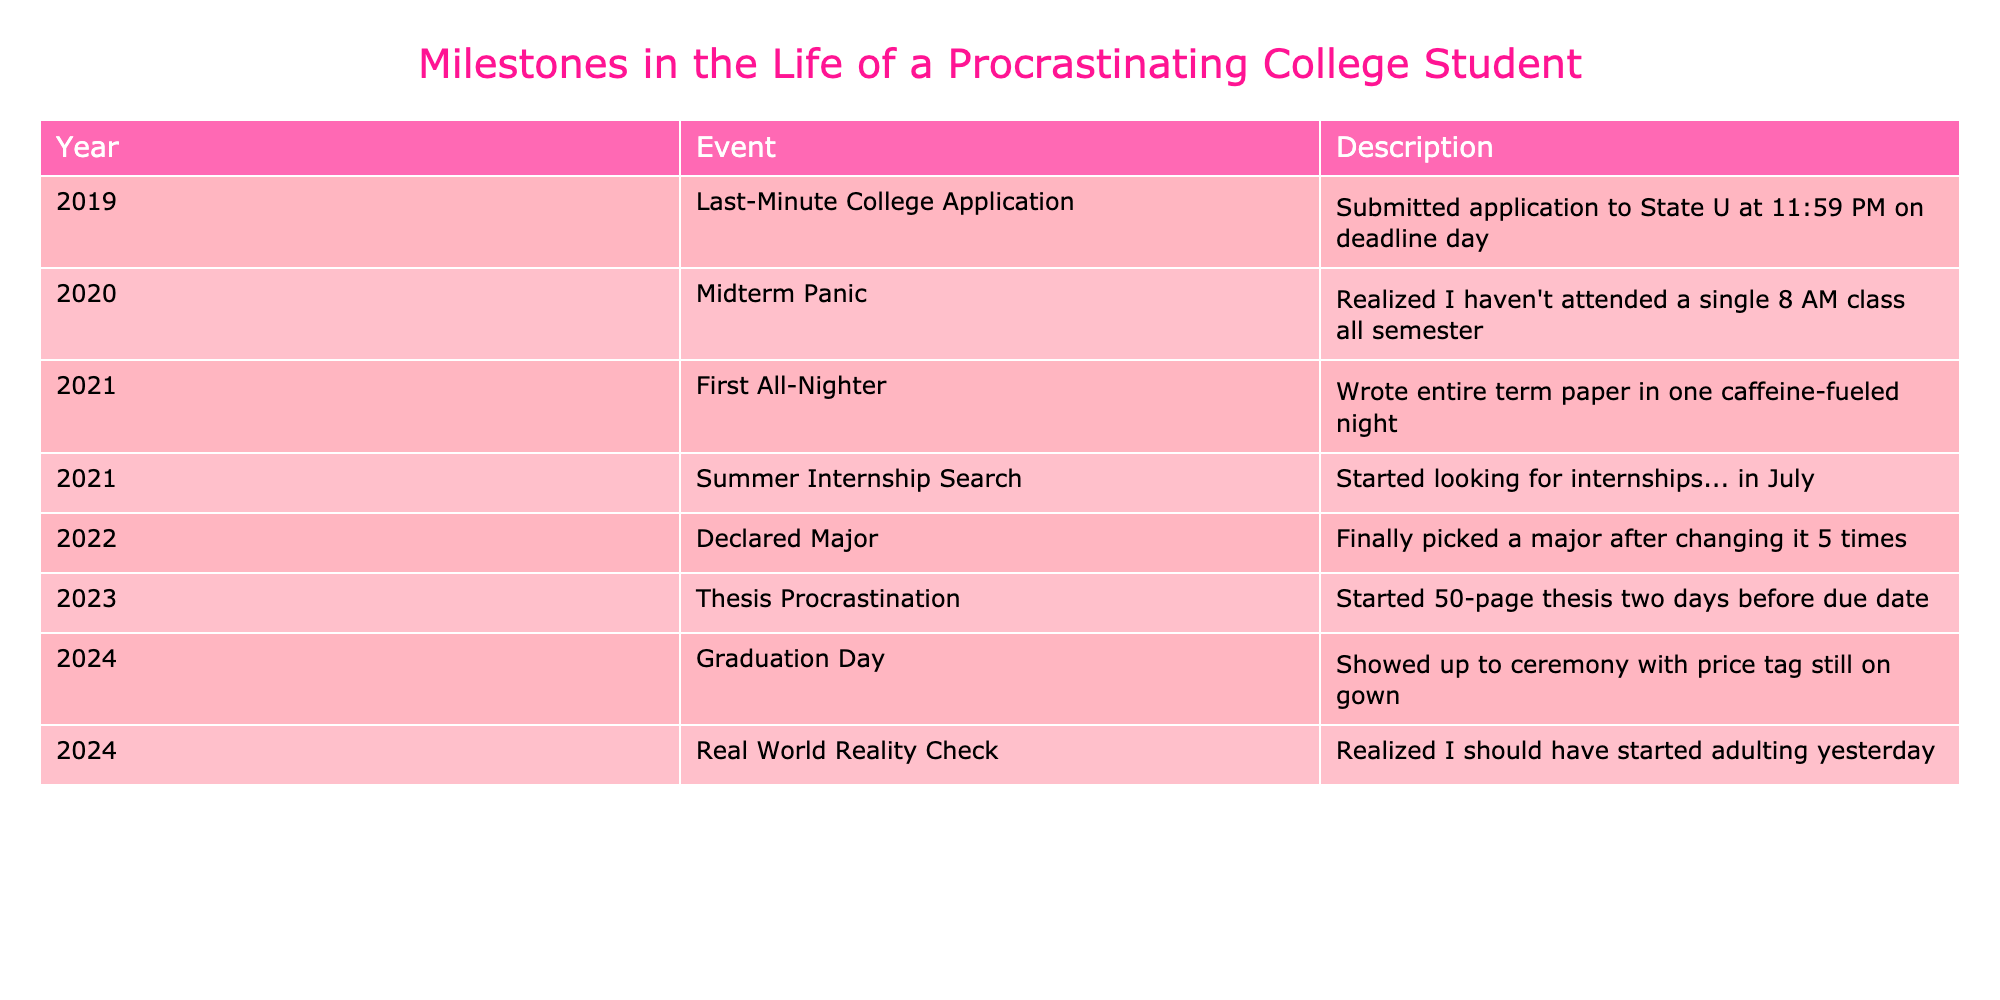What year did the student declare their major? The table shows that the student declared their major in the year 2022. This information can be directly retrieved from the "Year" column of the "Declared Major" event.
Answer: 2022 How many events happened in the year 2021? The table lists two events for the year 2021: "First All-Nighter" and "Summer Internship Search." By counting these, we see there are two events listed for that year.
Answer: 2 Was the student's thesis started before or after the due date? The table indicates that the student started their thesis two days before the due date, which clearly states the timing. Thus, it affirms that the thesis process began prior to the deadline.
Answer: Before What is the difference in years between the "Summer Internship Search" and "Graduation Day"? The "Summer Internship Search" occurred in 2021 and "Graduation Day" took place in 2024. To find the difference: 2024 - 2021 = 3 years. Therefore, the gap between these two events is three years.
Answer: 3 How many changes did the student make to their major before declaring it? The description of the "Declared Major" event mentions that the student changed their major five times before settling on one. Hence, it indicates there were five changes made.
Answer: 5 What event occurred closest to the student's graduation day? Looking at the table, the "Thesis Procrastination" event occurred in 2023, while "Graduation Day" is in 2024. Since these events are one year apart, "Thesis Procrastination" is the event that occurred closest to graduation.
Answer: Thesis Procrastination Was the student's first all-nighter related to preparing for a midterm? The "First All-Nighter" was associated with writing a term paper, while the "Midterm Panic" event mentions not attending any 8 AM classes. Since these events are about different assessments (a term paper vs. a midterm), it is correct to answer no.
Answer: No What percentage of the listed events involved procrastination explicitly? From the table, five events explicitly mention procrastination or last-minute efforts; those are "Last-Minute College Application," "Midterm Panic," "First All-Nighter," "Thesis Procrastination," and "Real World Reality Check." The total number of events is eight. To calculate the percentage: (5/8)*100 = 62.5%.
Answer: 62.5% What can be inferred about the student's approach to deadlines over the years? Analyzing the events from 2019 to 2024, a pattern emerges where the student consistently leaves significant tasks (applications, internships, thesis) until the last possible moment. This trend supports the idea of chronic procrastination and suggests difficulty in managing time effectively.
Answer: Consistent procrastination 